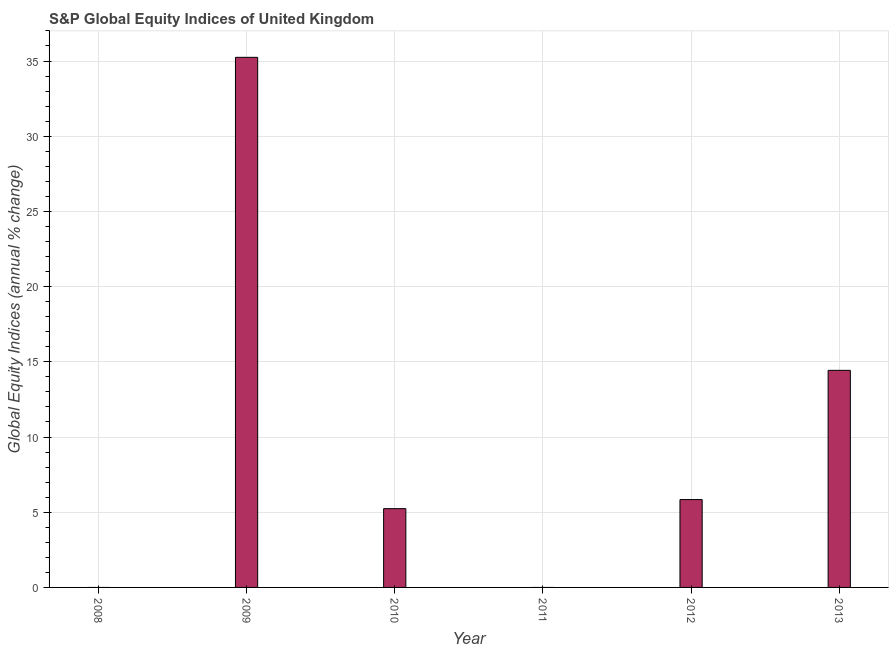What is the title of the graph?
Offer a terse response. S&P Global Equity Indices of United Kingdom. What is the label or title of the Y-axis?
Offer a very short reply. Global Equity Indices (annual % change). What is the s&p global equity indices in 2013?
Provide a succinct answer. 14.43. Across all years, what is the maximum s&p global equity indices?
Your answer should be compact. 35.25. Across all years, what is the minimum s&p global equity indices?
Your answer should be very brief. 0. What is the sum of the s&p global equity indices?
Provide a succinct answer. 60.76. What is the difference between the s&p global equity indices in 2009 and 2013?
Your answer should be very brief. 20.81. What is the average s&p global equity indices per year?
Ensure brevity in your answer.  10.13. What is the median s&p global equity indices?
Make the answer very short. 5.54. What is the ratio of the s&p global equity indices in 2010 to that in 2012?
Provide a short and direct response. 0.9. Is the s&p global equity indices in 2010 less than that in 2013?
Your answer should be compact. Yes. What is the difference between the highest and the second highest s&p global equity indices?
Your response must be concise. 20.81. What is the difference between the highest and the lowest s&p global equity indices?
Provide a short and direct response. 35.25. How many bars are there?
Ensure brevity in your answer.  4. Are all the bars in the graph horizontal?
Your response must be concise. No. Are the values on the major ticks of Y-axis written in scientific E-notation?
Your answer should be very brief. No. What is the Global Equity Indices (annual % change) in 2008?
Ensure brevity in your answer.  0. What is the Global Equity Indices (annual % change) of 2009?
Provide a short and direct response. 35.25. What is the Global Equity Indices (annual % change) in 2010?
Give a very brief answer. 5.24. What is the Global Equity Indices (annual % change) of 2011?
Ensure brevity in your answer.  0. What is the Global Equity Indices (annual % change) in 2012?
Your answer should be very brief. 5.84. What is the Global Equity Indices (annual % change) of 2013?
Provide a short and direct response. 14.43. What is the difference between the Global Equity Indices (annual % change) in 2009 and 2010?
Offer a terse response. 30.01. What is the difference between the Global Equity Indices (annual % change) in 2009 and 2012?
Provide a succinct answer. 29.4. What is the difference between the Global Equity Indices (annual % change) in 2009 and 2013?
Offer a terse response. 20.81. What is the difference between the Global Equity Indices (annual % change) in 2010 and 2012?
Ensure brevity in your answer.  -0.6. What is the difference between the Global Equity Indices (annual % change) in 2010 and 2013?
Your response must be concise. -9.2. What is the difference between the Global Equity Indices (annual % change) in 2012 and 2013?
Provide a succinct answer. -8.59. What is the ratio of the Global Equity Indices (annual % change) in 2009 to that in 2010?
Offer a terse response. 6.73. What is the ratio of the Global Equity Indices (annual % change) in 2009 to that in 2012?
Make the answer very short. 6.03. What is the ratio of the Global Equity Indices (annual % change) in 2009 to that in 2013?
Your answer should be compact. 2.44. What is the ratio of the Global Equity Indices (annual % change) in 2010 to that in 2012?
Give a very brief answer. 0.9. What is the ratio of the Global Equity Indices (annual % change) in 2010 to that in 2013?
Offer a terse response. 0.36. What is the ratio of the Global Equity Indices (annual % change) in 2012 to that in 2013?
Keep it short and to the point. 0.41. 